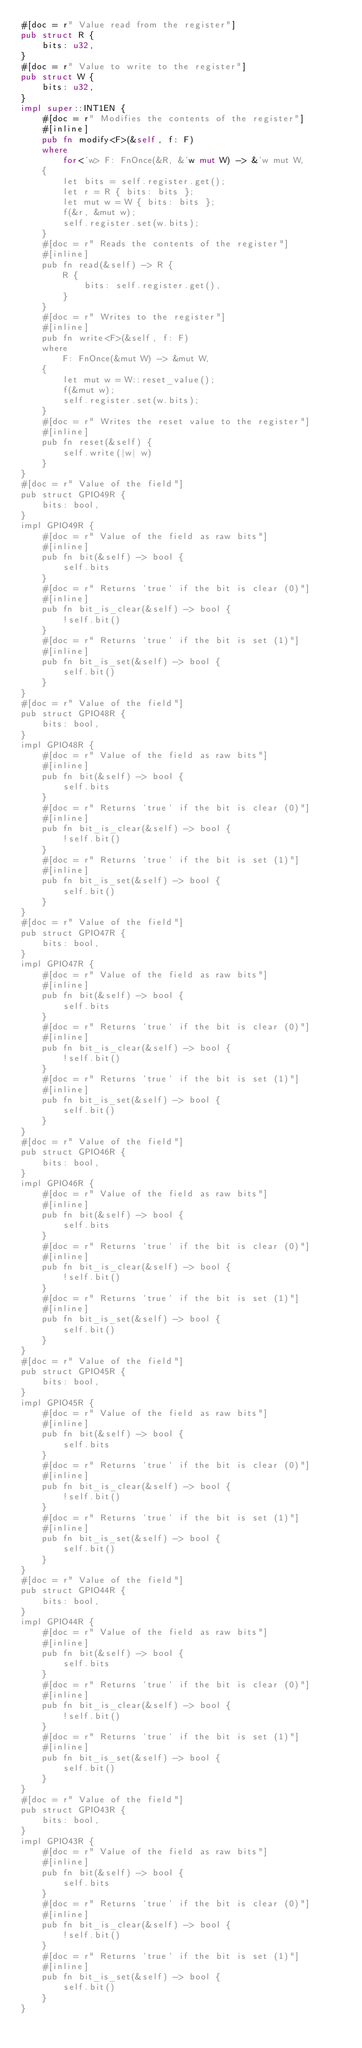<code> <loc_0><loc_0><loc_500><loc_500><_Rust_>#[doc = r" Value read from the register"]
pub struct R {
    bits: u32,
}
#[doc = r" Value to write to the register"]
pub struct W {
    bits: u32,
}
impl super::INT1EN {
    #[doc = r" Modifies the contents of the register"]
    #[inline]
    pub fn modify<F>(&self, f: F)
    where
        for<'w> F: FnOnce(&R, &'w mut W) -> &'w mut W,
    {
        let bits = self.register.get();
        let r = R { bits: bits };
        let mut w = W { bits: bits };
        f(&r, &mut w);
        self.register.set(w.bits);
    }
    #[doc = r" Reads the contents of the register"]
    #[inline]
    pub fn read(&self) -> R {
        R {
            bits: self.register.get(),
        }
    }
    #[doc = r" Writes to the register"]
    #[inline]
    pub fn write<F>(&self, f: F)
    where
        F: FnOnce(&mut W) -> &mut W,
    {
        let mut w = W::reset_value();
        f(&mut w);
        self.register.set(w.bits);
    }
    #[doc = r" Writes the reset value to the register"]
    #[inline]
    pub fn reset(&self) {
        self.write(|w| w)
    }
}
#[doc = r" Value of the field"]
pub struct GPIO49R {
    bits: bool,
}
impl GPIO49R {
    #[doc = r" Value of the field as raw bits"]
    #[inline]
    pub fn bit(&self) -> bool {
        self.bits
    }
    #[doc = r" Returns `true` if the bit is clear (0)"]
    #[inline]
    pub fn bit_is_clear(&self) -> bool {
        !self.bit()
    }
    #[doc = r" Returns `true` if the bit is set (1)"]
    #[inline]
    pub fn bit_is_set(&self) -> bool {
        self.bit()
    }
}
#[doc = r" Value of the field"]
pub struct GPIO48R {
    bits: bool,
}
impl GPIO48R {
    #[doc = r" Value of the field as raw bits"]
    #[inline]
    pub fn bit(&self) -> bool {
        self.bits
    }
    #[doc = r" Returns `true` if the bit is clear (0)"]
    #[inline]
    pub fn bit_is_clear(&self) -> bool {
        !self.bit()
    }
    #[doc = r" Returns `true` if the bit is set (1)"]
    #[inline]
    pub fn bit_is_set(&self) -> bool {
        self.bit()
    }
}
#[doc = r" Value of the field"]
pub struct GPIO47R {
    bits: bool,
}
impl GPIO47R {
    #[doc = r" Value of the field as raw bits"]
    #[inline]
    pub fn bit(&self) -> bool {
        self.bits
    }
    #[doc = r" Returns `true` if the bit is clear (0)"]
    #[inline]
    pub fn bit_is_clear(&self) -> bool {
        !self.bit()
    }
    #[doc = r" Returns `true` if the bit is set (1)"]
    #[inline]
    pub fn bit_is_set(&self) -> bool {
        self.bit()
    }
}
#[doc = r" Value of the field"]
pub struct GPIO46R {
    bits: bool,
}
impl GPIO46R {
    #[doc = r" Value of the field as raw bits"]
    #[inline]
    pub fn bit(&self) -> bool {
        self.bits
    }
    #[doc = r" Returns `true` if the bit is clear (0)"]
    #[inline]
    pub fn bit_is_clear(&self) -> bool {
        !self.bit()
    }
    #[doc = r" Returns `true` if the bit is set (1)"]
    #[inline]
    pub fn bit_is_set(&self) -> bool {
        self.bit()
    }
}
#[doc = r" Value of the field"]
pub struct GPIO45R {
    bits: bool,
}
impl GPIO45R {
    #[doc = r" Value of the field as raw bits"]
    #[inline]
    pub fn bit(&self) -> bool {
        self.bits
    }
    #[doc = r" Returns `true` if the bit is clear (0)"]
    #[inline]
    pub fn bit_is_clear(&self) -> bool {
        !self.bit()
    }
    #[doc = r" Returns `true` if the bit is set (1)"]
    #[inline]
    pub fn bit_is_set(&self) -> bool {
        self.bit()
    }
}
#[doc = r" Value of the field"]
pub struct GPIO44R {
    bits: bool,
}
impl GPIO44R {
    #[doc = r" Value of the field as raw bits"]
    #[inline]
    pub fn bit(&self) -> bool {
        self.bits
    }
    #[doc = r" Returns `true` if the bit is clear (0)"]
    #[inline]
    pub fn bit_is_clear(&self) -> bool {
        !self.bit()
    }
    #[doc = r" Returns `true` if the bit is set (1)"]
    #[inline]
    pub fn bit_is_set(&self) -> bool {
        self.bit()
    }
}
#[doc = r" Value of the field"]
pub struct GPIO43R {
    bits: bool,
}
impl GPIO43R {
    #[doc = r" Value of the field as raw bits"]
    #[inline]
    pub fn bit(&self) -> bool {
        self.bits
    }
    #[doc = r" Returns `true` if the bit is clear (0)"]
    #[inline]
    pub fn bit_is_clear(&self) -> bool {
        !self.bit()
    }
    #[doc = r" Returns `true` if the bit is set (1)"]
    #[inline]
    pub fn bit_is_set(&self) -> bool {
        self.bit()
    }
}</code> 